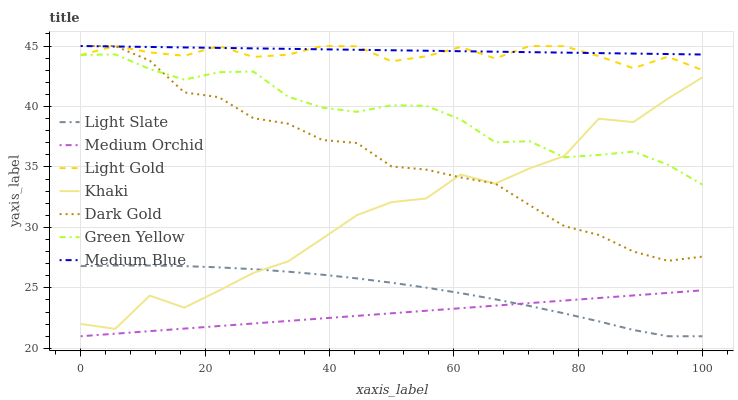Does Medium Orchid have the minimum area under the curve?
Answer yes or no. Yes. Does Medium Blue have the maximum area under the curve?
Answer yes or no. Yes. Does Dark Gold have the minimum area under the curve?
Answer yes or no. No. Does Dark Gold have the maximum area under the curve?
Answer yes or no. No. Is Medium Orchid the smoothest?
Answer yes or no. Yes. Is Khaki the roughest?
Answer yes or no. Yes. Is Dark Gold the smoothest?
Answer yes or no. No. Is Dark Gold the roughest?
Answer yes or no. No. Does Light Slate have the lowest value?
Answer yes or no. Yes. Does Dark Gold have the lowest value?
Answer yes or no. No. Does Light Gold have the highest value?
Answer yes or no. Yes. Does Light Slate have the highest value?
Answer yes or no. No. Is Light Slate less than Medium Blue?
Answer yes or no. Yes. Is Medium Blue greater than Medium Orchid?
Answer yes or no. Yes. Does Green Yellow intersect Khaki?
Answer yes or no. Yes. Is Green Yellow less than Khaki?
Answer yes or no. No. Is Green Yellow greater than Khaki?
Answer yes or no. No. Does Light Slate intersect Medium Blue?
Answer yes or no. No. 